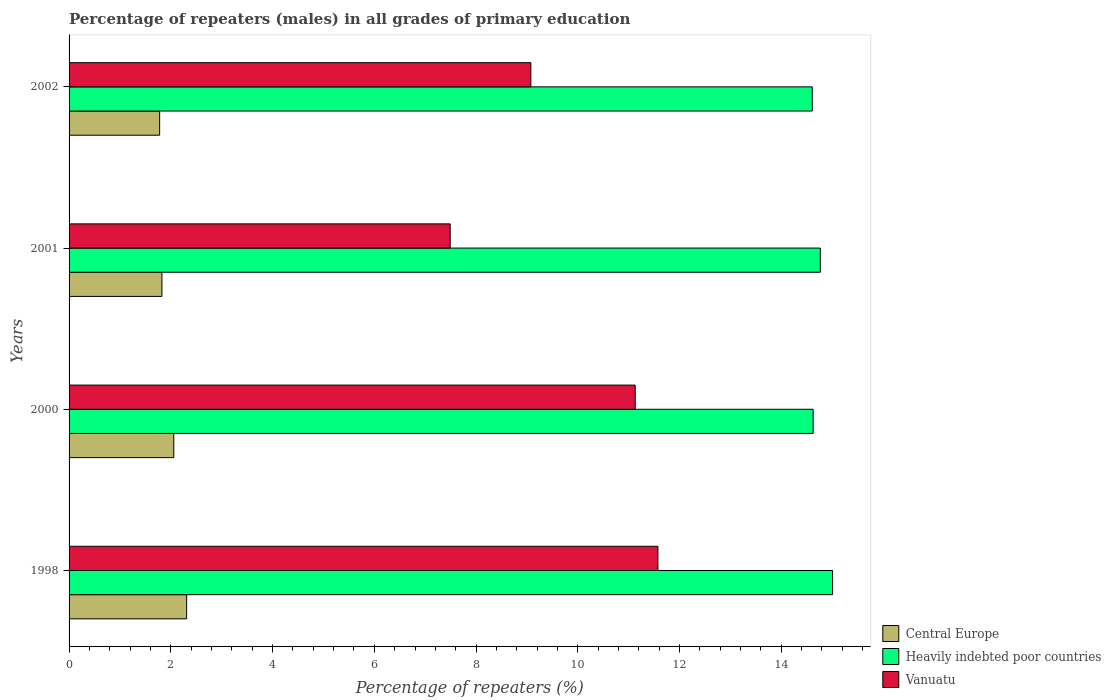Are the number of bars per tick equal to the number of legend labels?
Offer a terse response. Yes. How many bars are there on the 3rd tick from the top?
Give a very brief answer. 3. How many bars are there on the 2nd tick from the bottom?
Offer a terse response. 3. What is the label of the 4th group of bars from the top?
Keep it short and to the point. 1998. In how many cases, is the number of bars for a given year not equal to the number of legend labels?
Your answer should be very brief. 0. What is the percentage of repeaters (males) in Heavily indebted poor countries in 2000?
Your answer should be compact. 14.63. Across all years, what is the maximum percentage of repeaters (males) in Central Europe?
Offer a very short reply. 2.31. Across all years, what is the minimum percentage of repeaters (males) in Vanuatu?
Make the answer very short. 7.49. What is the total percentage of repeaters (males) in Vanuatu in the graph?
Your answer should be very brief. 39.27. What is the difference between the percentage of repeaters (males) in Central Europe in 2000 and that in 2001?
Ensure brevity in your answer.  0.23. What is the difference between the percentage of repeaters (males) in Central Europe in 2000 and the percentage of repeaters (males) in Vanuatu in 1998?
Provide a short and direct response. -9.52. What is the average percentage of repeaters (males) in Central Europe per year?
Offer a very short reply. 1.99. In the year 2002, what is the difference between the percentage of repeaters (males) in Vanuatu and percentage of repeaters (males) in Heavily indebted poor countries?
Provide a short and direct response. -5.53. In how many years, is the percentage of repeaters (males) in Central Europe greater than 13.2 %?
Your answer should be very brief. 0. What is the ratio of the percentage of repeaters (males) in Heavily indebted poor countries in 1998 to that in 2002?
Give a very brief answer. 1.03. Is the difference between the percentage of repeaters (males) in Vanuatu in 1998 and 2000 greater than the difference between the percentage of repeaters (males) in Heavily indebted poor countries in 1998 and 2000?
Offer a terse response. Yes. What is the difference between the highest and the second highest percentage of repeaters (males) in Heavily indebted poor countries?
Your answer should be very brief. 0.24. What is the difference between the highest and the lowest percentage of repeaters (males) in Vanuatu?
Provide a short and direct response. 4.08. Is the sum of the percentage of repeaters (males) in Heavily indebted poor countries in 1998 and 2000 greater than the maximum percentage of repeaters (males) in Central Europe across all years?
Your answer should be compact. Yes. What does the 2nd bar from the top in 2000 represents?
Your answer should be compact. Heavily indebted poor countries. What does the 1st bar from the bottom in 2001 represents?
Offer a terse response. Central Europe. Are all the bars in the graph horizontal?
Your response must be concise. Yes. How many years are there in the graph?
Give a very brief answer. 4. Are the values on the major ticks of X-axis written in scientific E-notation?
Provide a succinct answer. No. Does the graph contain grids?
Make the answer very short. No. Where does the legend appear in the graph?
Your answer should be compact. Bottom right. How many legend labels are there?
Keep it short and to the point. 3. What is the title of the graph?
Ensure brevity in your answer.  Percentage of repeaters (males) in all grades of primary education. Does "Qatar" appear as one of the legend labels in the graph?
Provide a short and direct response. No. What is the label or title of the X-axis?
Your response must be concise. Percentage of repeaters (%). What is the Percentage of repeaters (%) in Central Europe in 1998?
Offer a terse response. 2.31. What is the Percentage of repeaters (%) in Heavily indebted poor countries in 1998?
Offer a terse response. 15.01. What is the Percentage of repeaters (%) in Vanuatu in 1998?
Your answer should be very brief. 11.58. What is the Percentage of repeaters (%) of Central Europe in 2000?
Give a very brief answer. 2.06. What is the Percentage of repeaters (%) of Heavily indebted poor countries in 2000?
Offer a terse response. 14.63. What is the Percentage of repeaters (%) in Vanuatu in 2000?
Make the answer very short. 11.13. What is the Percentage of repeaters (%) in Central Europe in 2001?
Offer a terse response. 1.83. What is the Percentage of repeaters (%) of Heavily indebted poor countries in 2001?
Your answer should be very brief. 14.77. What is the Percentage of repeaters (%) of Vanuatu in 2001?
Your answer should be very brief. 7.49. What is the Percentage of repeaters (%) in Central Europe in 2002?
Offer a terse response. 1.78. What is the Percentage of repeaters (%) of Heavily indebted poor countries in 2002?
Offer a terse response. 14.61. What is the Percentage of repeaters (%) of Vanuatu in 2002?
Keep it short and to the point. 9.08. Across all years, what is the maximum Percentage of repeaters (%) in Central Europe?
Provide a succinct answer. 2.31. Across all years, what is the maximum Percentage of repeaters (%) in Heavily indebted poor countries?
Keep it short and to the point. 15.01. Across all years, what is the maximum Percentage of repeaters (%) in Vanuatu?
Your response must be concise. 11.58. Across all years, what is the minimum Percentage of repeaters (%) of Central Europe?
Give a very brief answer. 1.78. Across all years, what is the minimum Percentage of repeaters (%) of Heavily indebted poor countries?
Ensure brevity in your answer.  14.61. Across all years, what is the minimum Percentage of repeaters (%) in Vanuatu?
Ensure brevity in your answer.  7.49. What is the total Percentage of repeaters (%) in Central Europe in the graph?
Keep it short and to the point. 7.98. What is the total Percentage of repeaters (%) of Heavily indebted poor countries in the graph?
Give a very brief answer. 59.01. What is the total Percentage of repeaters (%) in Vanuatu in the graph?
Your response must be concise. 39.27. What is the difference between the Percentage of repeaters (%) of Central Europe in 1998 and that in 2000?
Ensure brevity in your answer.  0.25. What is the difference between the Percentage of repeaters (%) of Heavily indebted poor countries in 1998 and that in 2000?
Make the answer very short. 0.38. What is the difference between the Percentage of repeaters (%) in Vanuatu in 1998 and that in 2000?
Your answer should be compact. 0.45. What is the difference between the Percentage of repeaters (%) in Central Europe in 1998 and that in 2001?
Offer a terse response. 0.49. What is the difference between the Percentage of repeaters (%) in Heavily indebted poor countries in 1998 and that in 2001?
Keep it short and to the point. 0.24. What is the difference between the Percentage of repeaters (%) of Vanuatu in 1998 and that in 2001?
Make the answer very short. 4.08. What is the difference between the Percentage of repeaters (%) of Central Europe in 1998 and that in 2002?
Give a very brief answer. 0.53. What is the difference between the Percentage of repeaters (%) of Heavily indebted poor countries in 1998 and that in 2002?
Give a very brief answer. 0.4. What is the difference between the Percentage of repeaters (%) of Vanuatu in 1998 and that in 2002?
Offer a terse response. 2.5. What is the difference between the Percentage of repeaters (%) in Central Europe in 2000 and that in 2001?
Provide a short and direct response. 0.23. What is the difference between the Percentage of repeaters (%) of Heavily indebted poor countries in 2000 and that in 2001?
Your answer should be compact. -0.14. What is the difference between the Percentage of repeaters (%) in Vanuatu in 2000 and that in 2001?
Your answer should be compact. 3.64. What is the difference between the Percentage of repeaters (%) in Central Europe in 2000 and that in 2002?
Your response must be concise. 0.28. What is the difference between the Percentage of repeaters (%) in Heavily indebted poor countries in 2000 and that in 2002?
Provide a succinct answer. 0.02. What is the difference between the Percentage of repeaters (%) of Vanuatu in 2000 and that in 2002?
Give a very brief answer. 2.05. What is the difference between the Percentage of repeaters (%) of Central Europe in 2001 and that in 2002?
Make the answer very short. 0.05. What is the difference between the Percentage of repeaters (%) in Heavily indebted poor countries in 2001 and that in 2002?
Your answer should be very brief. 0.16. What is the difference between the Percentage of repeaters (%) in Vanuatu in 2001 and that in 2002?
Provide a short and direct response. -1.59. What is the difference between the Percentage of repeaters (%) of Central Europe in 1998 and the Percentage of repeaters (%) of Heavily indebted poor countries in 2000?
Ensure brevity in your answer.  -12.32. What is the difference between the Percentage of repeaters (%) in Central Europe in 1998 and the Percentage of repeaters (%) in Vanuatu in 2000?
Provide a short and direct response. -8.82. What is the difference between the Percentage of repeaters (%) in Heavily indebted poor countries in 1998 and the Percentage of repeaters (%) in Vanuatu in 2000?
Keep it short and to the point. 3.88. What is the difference between the Percentage of repeaters (%) of Central Europe in 1998 and the Percentage of repeaters (%) of Heavily indebted poor countries in 2001?
Provide a short and direct response. -12.46. What is the difference between the Percentage of repeaters (%) of Central Europe in 1998 and the Percentage of repeaters (%) of Vanuatu in 2001?
Your answer should be very brief. -5.18. What is the difference between the Percentage of repeaters (%) in Heavily indebted poor countries in 1998 and the Percentage of repeaters (%) in Vanuatu in 2001?
Your answer should be very brief. 7.52. What is the difference between the Percentage of repeaters (%) of Central Europe in 1998 and the Percentage of repeaters (%) of Heavily indebted poor countries in 2002?
Provide a short and direct response. -12.3. What is the difference between the Percentage of repeaters (%) in Central Europe in 1998 and the Percentage of repeaters (%) in Vanuatu in 2002?
Offer a very short reply. -6.77. What is the difference between the Percentage of repeaters (%) in Heavily indebted poor countries in 1998 and the Percentage of repeaters (%) in Vanuatu in 2002?
Give a very brief answer. 5.93. What is the difference between the Percentage of repeaters (%) in Central Europe in 2000 and the Percentage of repeaters (%) in Heavily indebted poor countries in 2001?
Your answer should be compact. -12.71. What is the difference between the Percentage of repeaters (%) in Central Europe in 2000 and the Percentage of repeaters (%) in Vanuatu in 2001?
Give a very brief answer. -5.43. What is the difference between the Percentage of repeaters (%) in Heavily indebted poor countries in 2000 and the Percentage of repeaters (%) in Vanuatu in 2001?
Offer a terse response. 7.13. What is the difference between the Percentage of repeaters (%) of Central Europe in 2000 and the Percentage of repeaters (%) of Heavily indebted poor countries in 2002?
Your response must be concise. -12.55. What is the difference between the Percentage of repeaters (%) of Central Europe in 2000 and the Percentage of repeaters (%) of Vanuatu in 2002?
Provide a short and direct response. -7.02. What is the difference between the Percentage of repeaters (%) in Heavily indebted poor countries in 2000 and the Percentage of repeaters (%) in Vanuatu in 2002?
Your answer should be very brief. 5.55. What is the difference between the Percentage of repeaters (%) in Central Europe in 2001 and the Percentage of repeaters (%) in Heavily indebted poor countries in 2002?
Make the answer very short. -12.78. What is the difference between the Percentage of repeaters (%) in Central Europe in 2001 and the Percentage of repeaters (%) in Vanuatu in 2002?
Provide a succinct answer. -7.25. What is the difference between the Percentage of repeaters (%) in Heavily indebted poor countries in 2001 and the Percentage of repeaters (%) in Vanuatu in 2002?
Provide a succinct answer. 5.69. What is the average Percentage of repeaters (%) of Central Europe per year?
Provide a short and direct response. 1.99. What is the average Percentage of repeaters (%) of Heavily indebted poor countries per year?
Your response must be concise. 14.75. What is the average Percentage of repeaters (%) in Vanuatu per year?
Make the answer very short. 9.82. In the year 1998, what is the difference between the Percentage of repeaters (%) of Central Europe and Percentage of repeaters (%) of Heavily indebted poor countries?
Provide a succinct answer. -12.7. In the year 1998, what is the difference between the Percentage of repeaters (%) in Central Europe and Percentage of repeaters (%) in Vanuatu?
Make the answer very short. -9.26. In the year 1998, what is the difference between the Percentage of repeaters (%) in Heavily indebted poor countries and Percentage of repeaters (%) in Vanuatu?
Provide a short and direct response. 3.43. In the year 2000, what is the difference between the Percentage of repeaters (%) in Central Europe and Percentage of repeaters (%) in Heavily indebted poor countries?
Offer a very short reply. -12.57. In the year 2000, what is the difference between the Percentage of repeaters (%) of Central Europe and Percentage of repeaters (%) of Vanuatu?
Give a very brief answer. -9.07. In the year 2000, what is the difference between the Percentage of repeaters (%) in Heavily indebted poor countries and Percentage of repeaters (%) in Vanuatu?
Make the answer very short. 3.5. In the year 2001, what is the difference between the Percentage of repeaters (%) in Central Europe and Percentage of repeaters (%) in Heavily indebted poor countries?
Your answer should be very brief. -12.94. In the year 2001, what is the difference between the Percentage of repeaters (%) of Central Europe and Percentage of repeaters (%) of Vanuatu?
Make the answer very short. -5.67. In the year 2001, what is the difference between the Percentage of repeaters (%) of Heavily indebted poor countries and Percentage of repeaters (%) of Vanuatu?
Ensure brevity in your answer.  7.28. In the year 2002, what is the difference between the Percentage of repeaters (%) of Central Europe and Percentage of repeaters (%) of Heavily indebted poor countries?
Your response must be concise. -12.83. In the year 2002, what is the difference between the Percentage of repeaters (%) of Central Europe and Percentage of repeaters (%) of Vanuatu?
Give a very brief answer. -7.3. In the year 2002, what is the difference between the Percentage of repeaters (%) of Heavily indebted poor countries and Percentage of repeaters (%) of Vanuatu?
Keep it short and to the point. 5.53. What is the ratio of the Percentage of repeaters (%) in Central Europe in 1998 to that in 2000?
Your answer should be compact. 1.12. What is the ratio of the Percentage of repeaters (%) in Heavily indebted poor countries in 1998 to that in 2000?
Provide a succinct answer. 1.03. What is the ratio of the Percentage of repeaters (%) in Vanuatu in 1998 to that in 2000?
Offer a terse response. 1.04. What is the ratio of the Percentage of repeaters (%) in Central Europe in 1998 to that in 2001?
Provide a short and direct response. 1.27. What is the ratio of the Percentage of repeaters (%) in Heavily indebted poor countries in 1998 to that in 2001?
Your answer should be very brief. 1.02. What is the ratio of the Percentage of repeaters (%) in Vanuatu in 1998 to that in 2001?
Ensure brevity in your answer.  1.54. What is the ratio of the Percentage of repeaters (%) of Central Europe in 1998 to that in 2002?
Keep it short and to the point. 1.3. What is the ratio of the Percentage of repeaters (%) in Heavily indebted poor countries in 1998 to that in 2002?
Offer a terse response. 1.03. What is the ratio of the Percentage of repeaters (%) of Vanuatu in 1998 to that in 2002?
Ensure brevity in your answer.  1.28. What is the ratio of the Percentage of repeaters (%) in Central Europe in 2000 to that in 2001?
Your answer should be very brief. 1.13. What is the ratio of the Percentage of repeaters (%) in Heavily indebted poor countries in 2000 to that in 2001?
Provide a succinct answer. 0.99. What is the ratio of the Percentage of repeaters (%) in Vanuatu in 2000 to that in 2001?
Provide a succinct answer. 1.49. What is the ratio of the Percentage of repeaters (%) of Central Europe in 2000 to that in 2002?
Give a very brief answer. 1.16. What is the ratio of the Percentage of repeaters (%) in Vanuatu in 2000 to that in 2002?
Provide a short and direct response. 1.23. What is the ratio of the Percentage of repeaters (%) in Central Europe in 2001 to that in 2002?
Make the answer very short. 1.03. What is the ratio of the Percentage of repeaters (%) in Heavily indebted poor countries in 2001 to that in 2002?
Ensure brevity in your answer.  1.01. What is the ratio of the Percentage of repeaters (%) in Vanuatu in 2001 to that in 2002?
Give a very brief answer. 0.83. What is the difference between the highest and the second highest Percentage of repeaters (%) of Central Europe?
Make the answer very short. 0.25. What is the difference between the highest and the second highest Percentage of repeaters (%) of Heavily indebted poor countries?
Ensure brevity in your answer.  0.24. What is the difference between the highest and the second highest Percentage of repeaters (%) in Vanuatu?
Ensure brevity in your answer.  0.45. What is the difference between the highest and the lowest Percentage of repeaters (%) in Central Europe?
Your answer should be very brief. 0.53. What is the difference between the highest and the lowest Percentage of repeaters (%) of Heavily indebted poor countries?
Provide a succinct answer. 0.4. What is the difference between the highest and the lowest Percentage of repeaters (%) of Vanuatu?
Give a very brief answer. 4.08. 